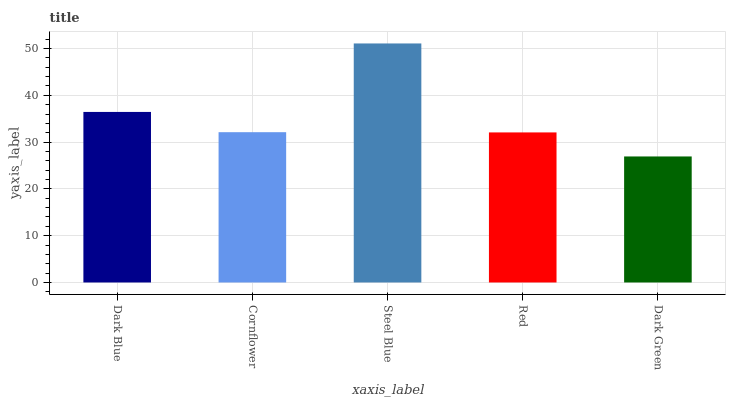Is Cornflower the minimum?
Answer yes or no. No. Is Cornflower the maximum?
Answer yes or no. No. Is Dark Blue greater than Cornflower?
Answer yes or no. Yes. Is Cornflower less than Dark Blue?
Answer yes or no. Yes. Is Cornflower greater than Dark Blue?
Answer yes or no. No. Is Dark Blue less than Cornflower?
Answer yes or no. No. Is Cornflower the high median?
Answer yes or no. Yes. Is Cornflower the low median?
Answer yes or no. Yes. Is Steel Blue the high median?
Answer yes or no. No. Is Steel Blue the low median?
Answer yes or no. No. 